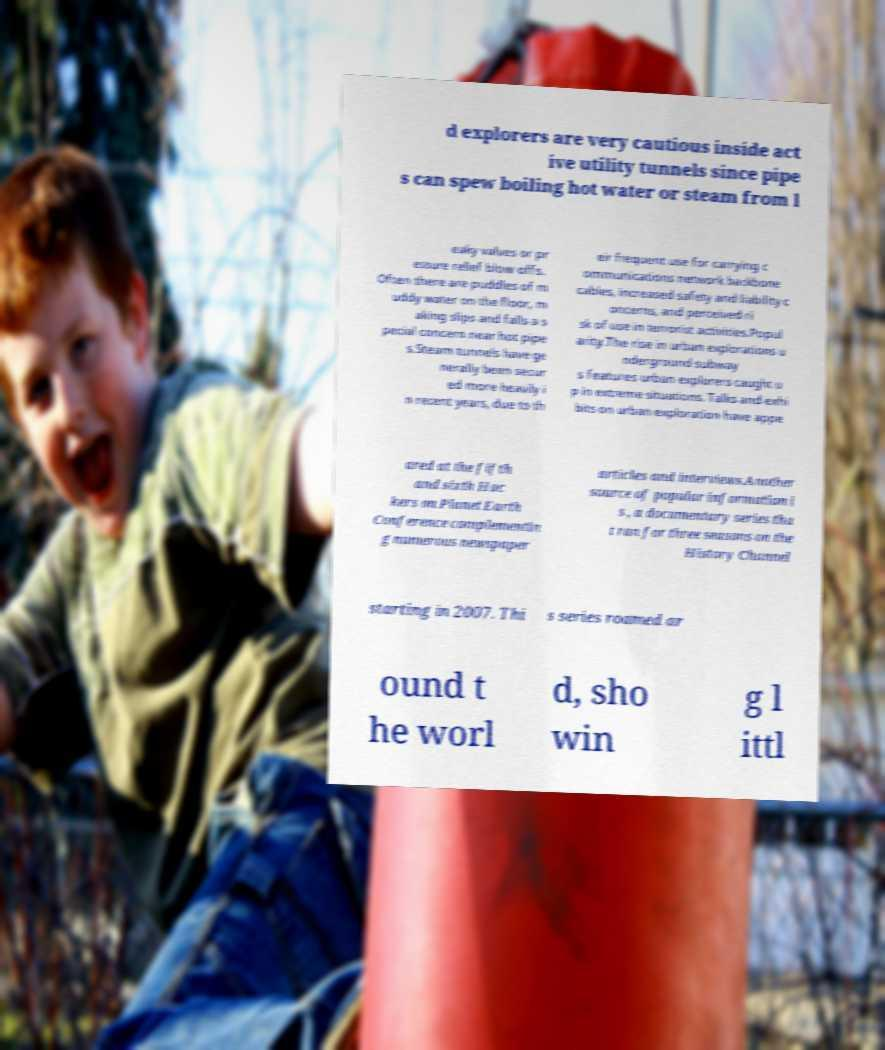There's text embedded in this image that I need extracted. Can you transcribe it verbatim? d explorers are very cautious inside act ive utility tunnels since pipe s can spew boiling hot water or steam from l eaky valves or pr essure relief blow offs. Often there are puddles of m uddy water on the floor, m aking slips and falls a s pecial concern near hot pipe s.Steam tunnels have ge nerally been secur ed more heavily i n recent years, due to th eir frequent use for carrying c ommunications network backbone cables, increased safety and liability c oncerns, and perceived ri sk of use in terrorist activities.Popul arity.The rise in urban explorations u nderground subway s features urban explorers caught u p in extreme situations. Talks and exhi bits on urban exploration have appe ared at the fifth and sixth Hac kers on Planet Earth Conference complementin g numerous newspaper articles and interviews.Another source of popular information i s , a documentary series tha t ran for three seasons on the History Channel starting in 2007. Thi s series roamed ar ound t he worl d, sho win g l ittl 